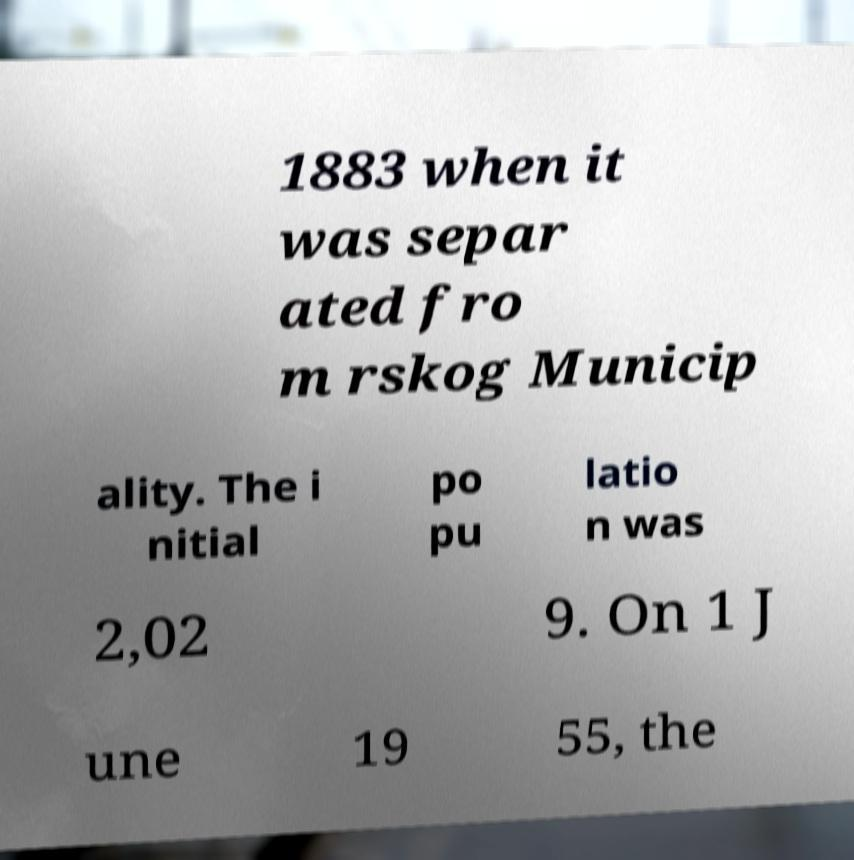Could you assist in decoding the text presented in this image and type it out clearly? 1883 when it was separ ated fro m rskog Municip ality. The i nitial po pu latio n was 2,02 9. On 1 J une 19 55, the 